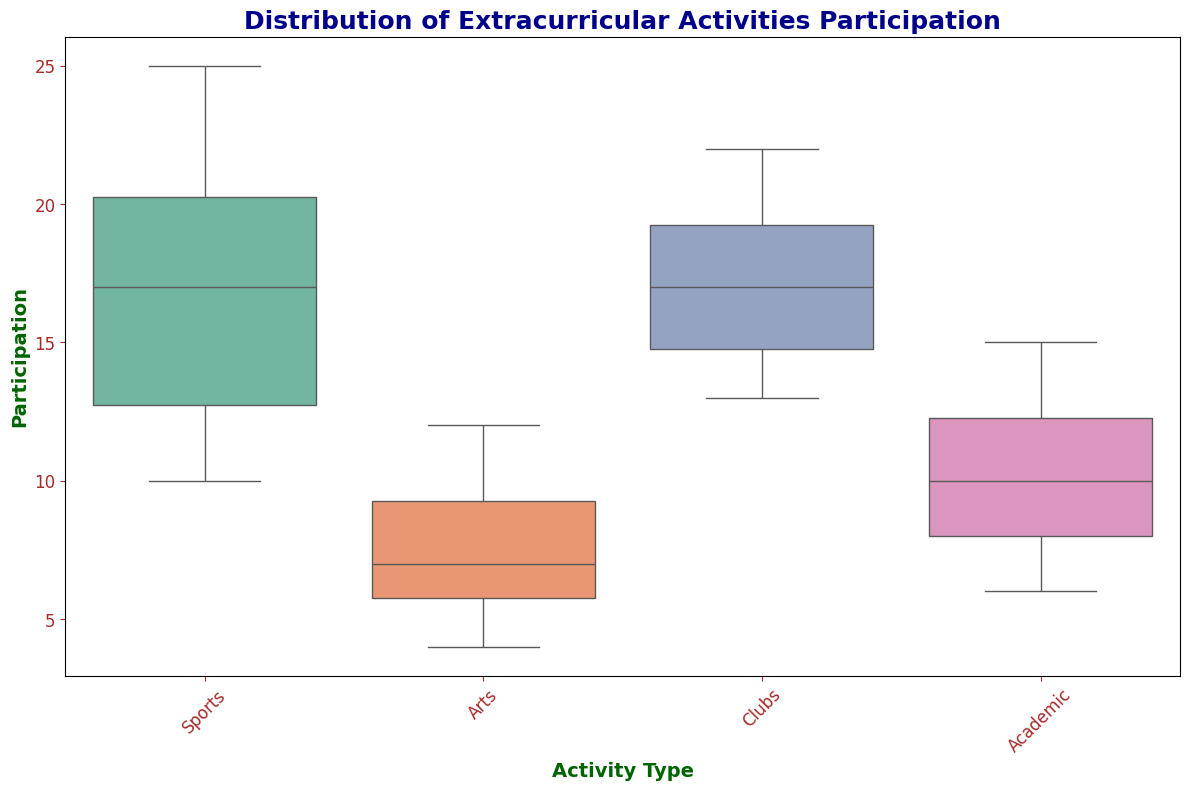What's the median participation in Sports? Look at the box plot for the Sports category and identify the middle value (median) represented by the line inside the box.
Answer: 16 Which activity type has the highest median participation? Compare the median values represented by the lines inside the boxes for all activity types. Sports has the highest median line.
Answer: Sports Which activity type has the largest range of participation? The range is the distance between the maximum and minimum values. Observing the length of the boxes and whiskers, Sports has the widest spread from minimum to maximum.
Answer: Sports How does the median participation in Arts compare to Clubs? Identify the median lines in the boxes for Arts and Clubs. The median for Arts is lower than that for Clubs.
Answer: Closer to the lower end in Arts What's the interquartile range (IQR) of participation in Academic activities? The IQR is the length of the box. Locate the bottom and top of the box for Academic activities and calculate the difference: the box stretches from the first quartile (lower edge) to the third quartile (upper edge). The approximate range seems to be from 8 to 13.
Answer: 5 Between Arts and Academic activities, which one has a higher maximum value? Look at the top end of the whiskers for both Arts and Academic activities. Academic activities have a whisker extending higher than Arts.
Answer: Academic What is the minimum participation in Clubs? Locate the bottom whisker for Clubs and read the corresponding value.
Answer: 13 Is the participation in Sports more spread out compared to Academic activities? Examine the length of the boxes and whiskers of both activity types. Sports has a wider spread (larger range) than Academic activities.
Answer: Yes Among the activity types, which one shows the least variability in participation? Least variability is indicated by the smallest box and whisker length. The Arts category has the least spread, thus the least variability.
Answer: Arts By how much does the median participation in Clubs exceed that of Arts? Locate the median lines for Clubs and Arts and subtract the median of Arts from the median of Clubs: approximately 16 (Clubs) - 7 (Arts).
Answer: 9 